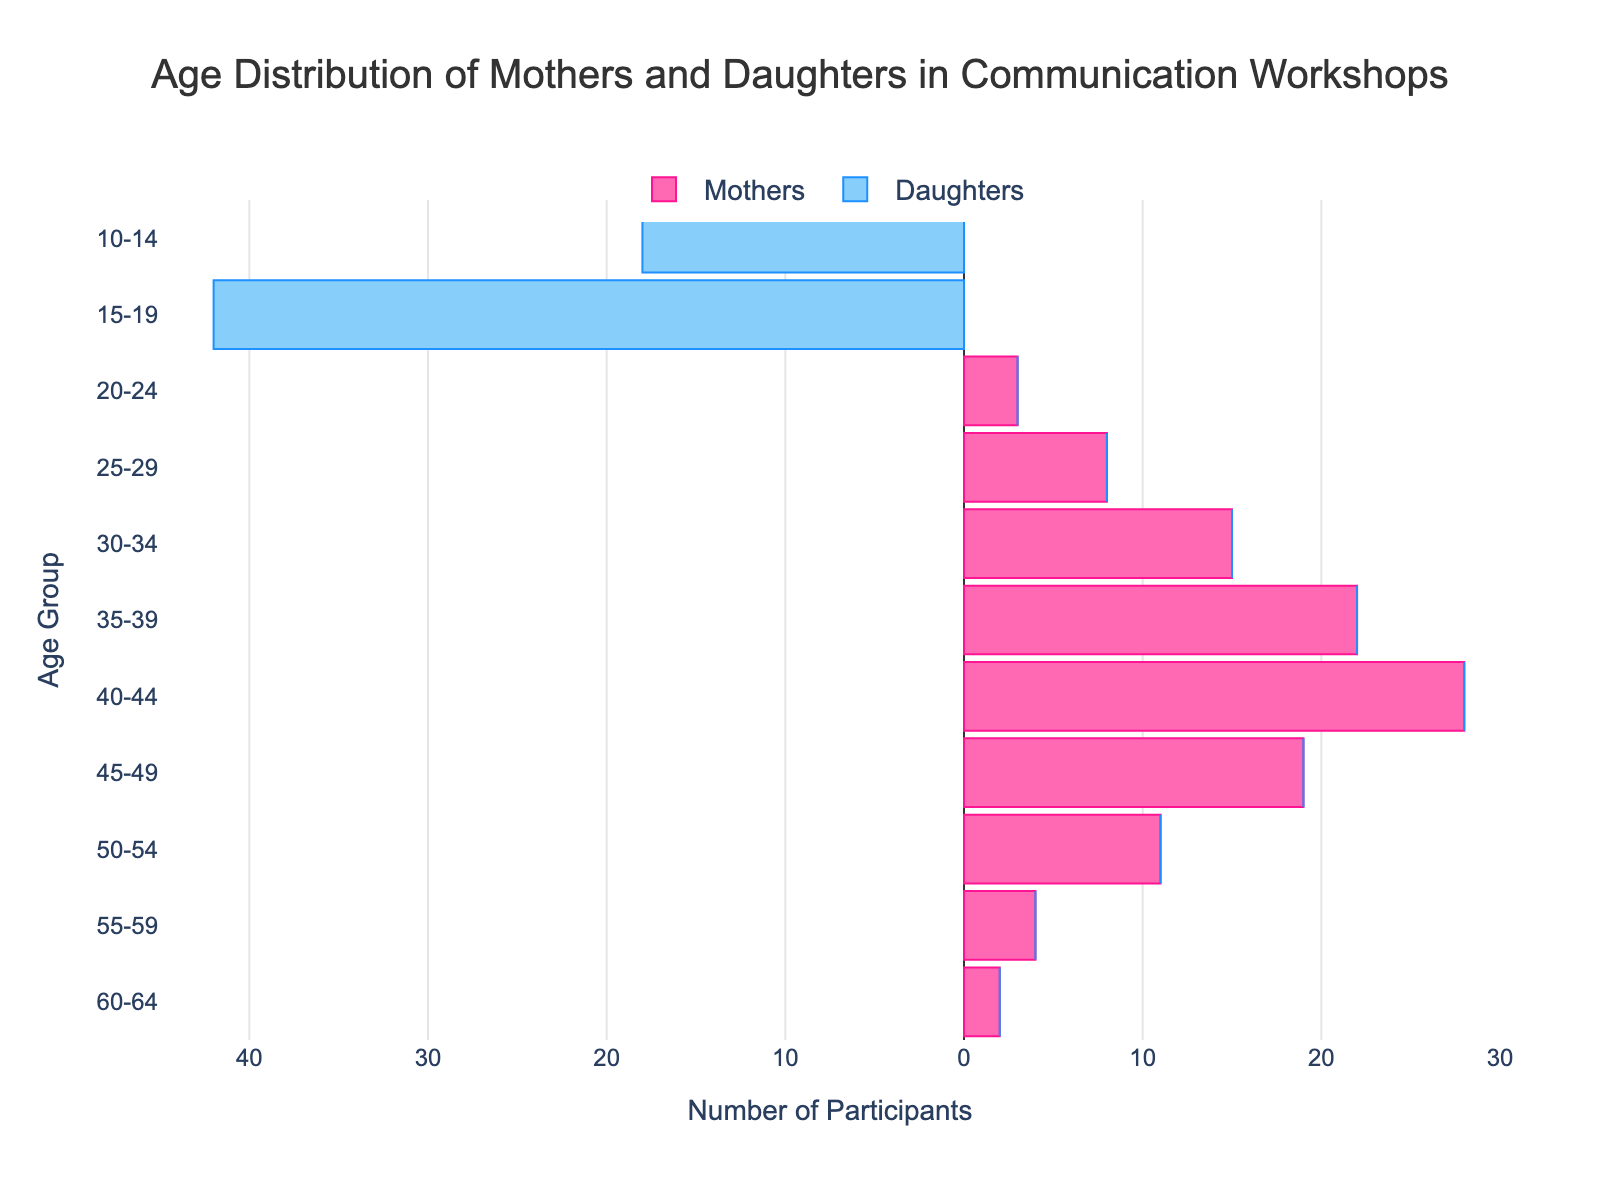What's the title of the figure? The title of the figure is located at the top and reads "Age Distribution of Mothers and Daughters in Communication Workshops".
Answer: Age Distribution of Mothers and Daughters in Communication Workshops Which age group has the highest number of mothers participating? To find the age group with the highest number of mothers, look at the pink bars. The age group 40-44 has the longest pink bar, representing the highest number of mothers.
Answer: 40-44 How many daughters participated in the 10-14 age group? The number of daughters in each age group is represented by the blue bars. For the 10-14 age group, the length of the blue bar represents 18 participants.
Answer: 18 How many more participants are there in the 15-19 daughter's group compared to the 10-14 daughter's group? To find the difference, subtract the number of daughters in the 10-14 age group (18) from the number in the 15-19 age group (42). 42 - 18 = 24.
Answer: 24 Which group (mothers or daughters) is more numerous in the 20-24 age group? In the 20-24 age group, only the mothers' bar (pink) is present, indicating mothers are more numerous since no daughters are represented.
Answer: Mothers What is the total number of mothers in the 30-39 age group? Add the mothers of the 30-34 and 35-39 age groups. The count is 15 + 22 = 37.
Answer: 37 How does the participation of daughters in the 15-19 age group compare to the participation of mothers in the 40-44 age group? Compare the lengths of the bars for daughters in 15-19 (42) and mothers in 40-44 (28). Participation of daughters in the 15-19 age group (42) is greater than mothers in the 40-44 age group (28).
Answer: Daughters in the 15-19 age group are more numerous What's the range of ages for mothers participating in the workshops? The age groups for mothers start from 20-24 and go up to 60-64, so the range is 20-64 years.
Answer: 20-64 What is the difference in participants between the mothers' group in 45-49 and the daughters' group in 15-19? The mothers in the 45-49 age group number 19, and the daughters in the 15-19 age group number 42. The difference is calculated as 42 - 19 = 23 participants.
Answer: 23 